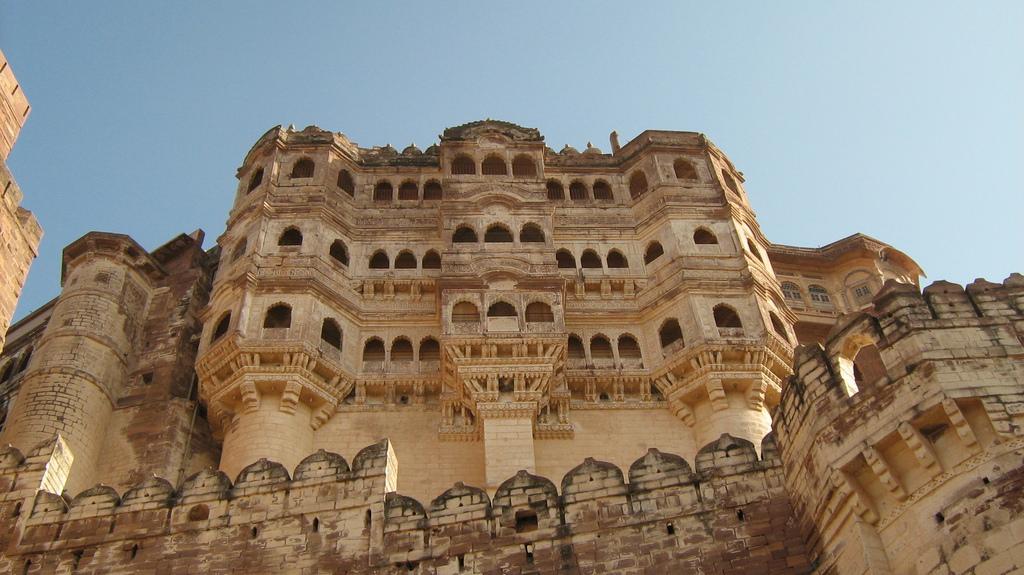How would you summarize this image in a sentence or two? In the image we can see there are buildings and the buildings are made up of stone bricks. The sky is clear. 